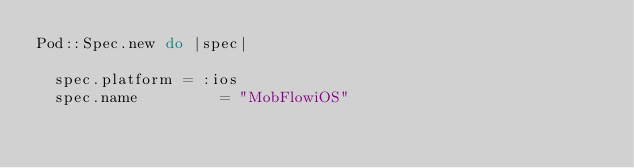Convert code to text. <code><loc_0><loc_0><loc_500><loc_500><_Ruby_>Pod::Spec.new do |spec|

  spec.platform = :ios
  spec.name         = "MobFlowiOS"</code> 